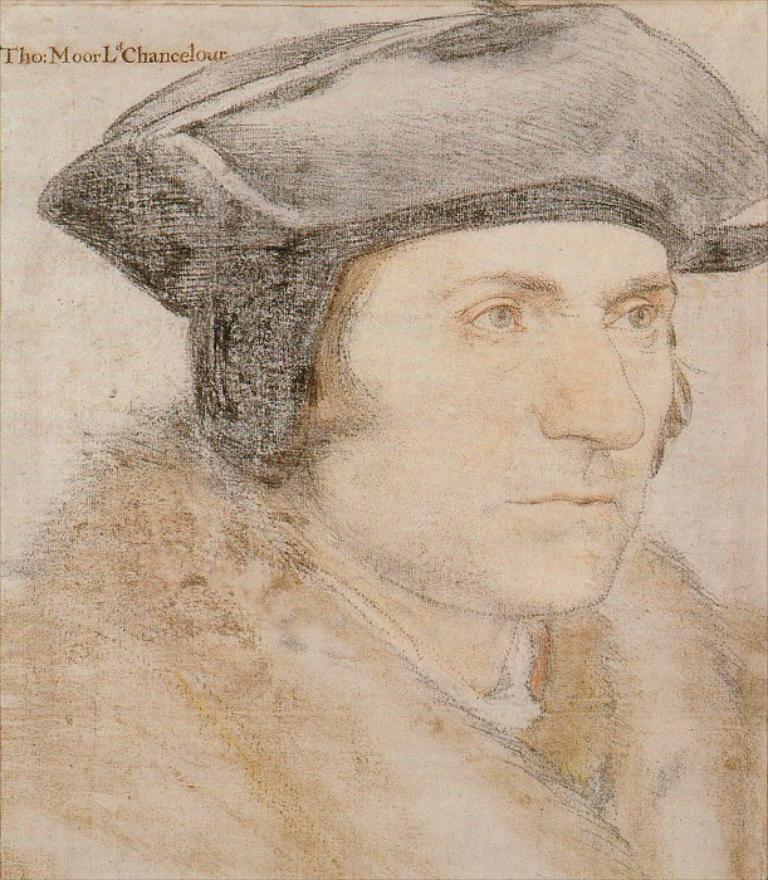Please provide a concise description of this image. In the image there is a sketch of a man. 